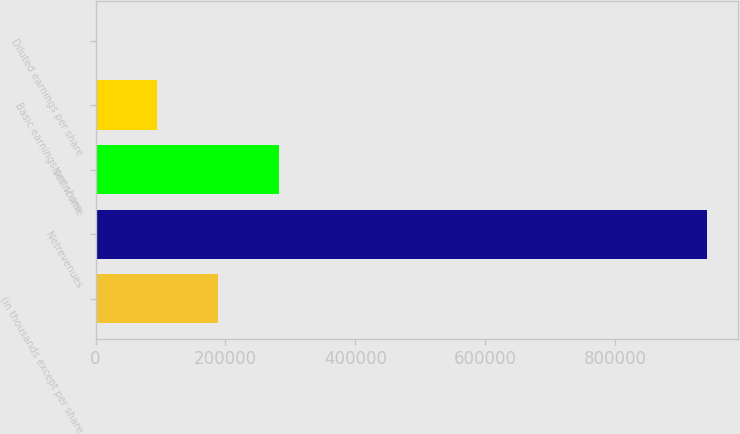<chart> <loc_0><loc_0><loc_500><loc_500><bar_chart><fcel>(in thousands except per share<fcel>Netrevenues<fcel>Netincome<fcel>Basic earnings per share<fcel>Diluted earnings per share<nl><fcel>188336<fcel>941678<fcel>282504<fcel>94168.5<fcel>0.73<nl></chart> 